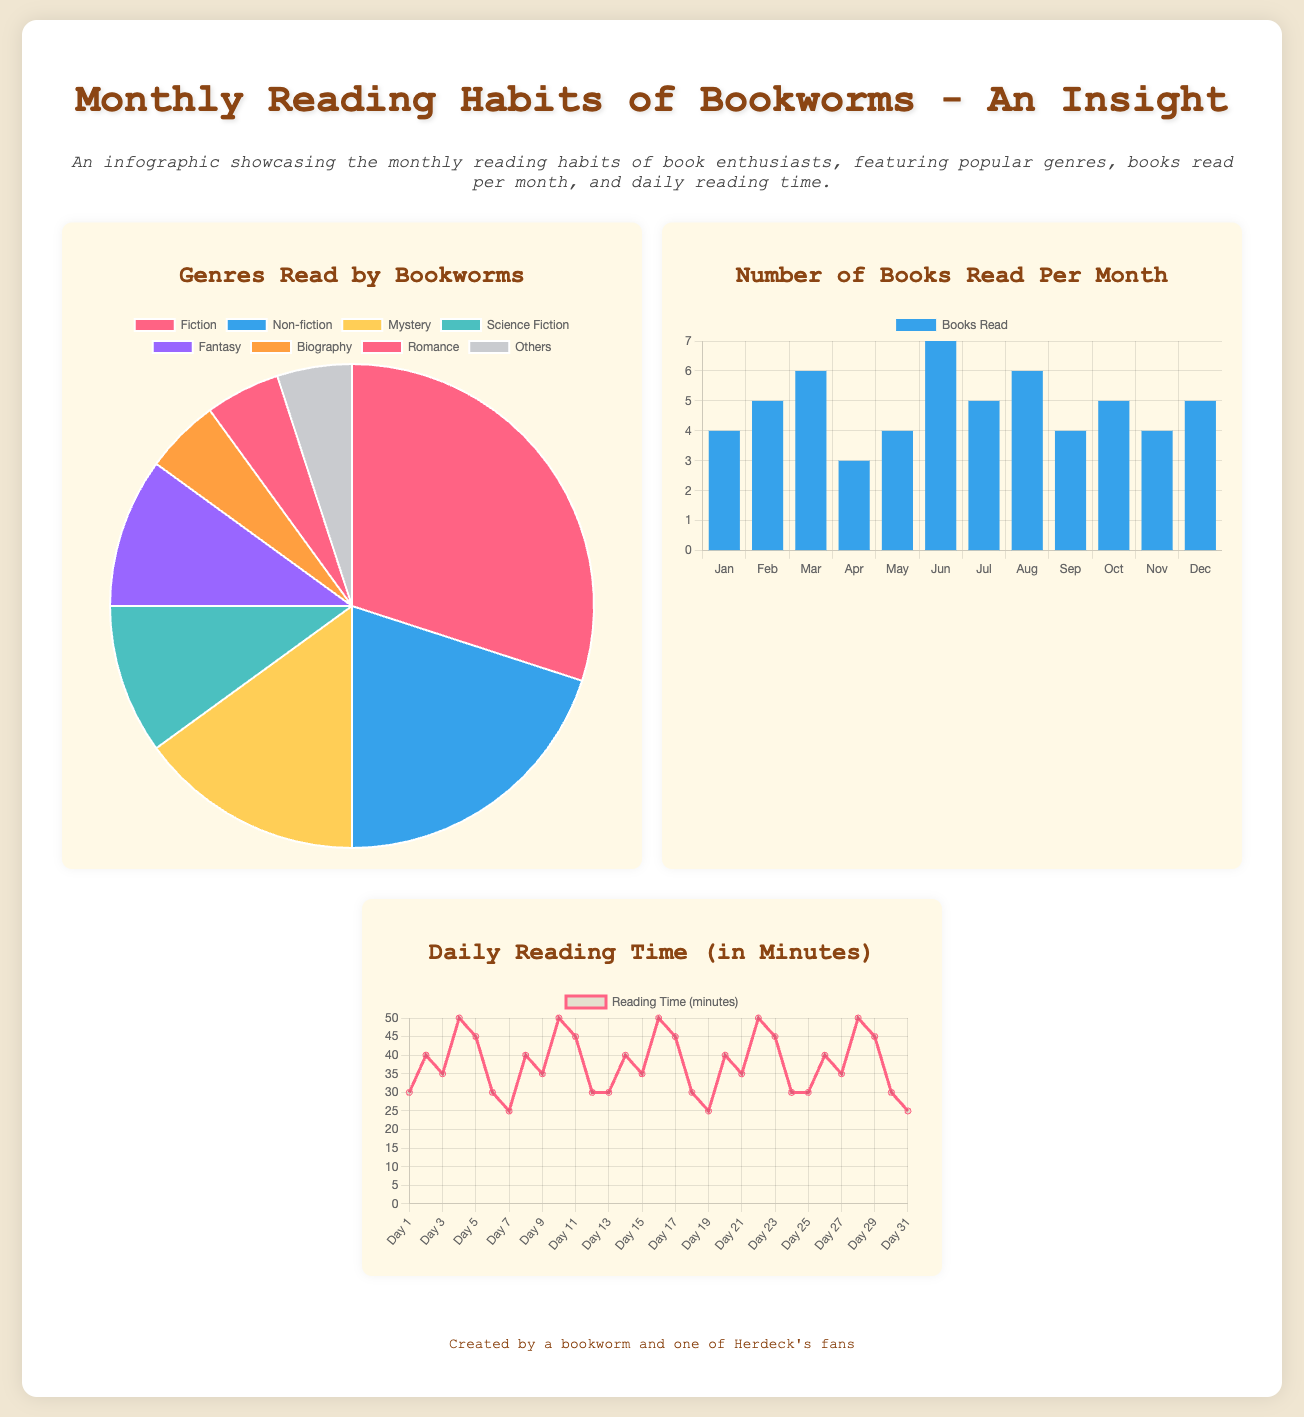What is the most popular genre among bookworms? The pie chart shows the distribution of genres read by bookworms, where Fiction makes up the largest segment.
Answer: Fiction How many books were read in March? The bar graph indicates the number of books read in each month, showing that 6 books were read in March.
Answer: 6 What is the average daily reading time for bookworms in minutes? The line chart presents daily reading times, demonstrating a varied average; a quick review reveals values around 35-45 minutes per day.
Answer: Approximately 35-45 minutes How many genres are listed in the infographic? The pie chart displays the genre data, and upon counting, there are 8 distinct genres displayed.
Answer: 8 What month had the highest number of books read? The bar graph indicates that June had the highest number of books read with a total of 7 books.
Answer: June What is the reading time on Day 10? From the line chart, it can be observed that on Day 10, the reading time was recorded as 50 minutes.
Answer: 50 minutes Which genre has the smallest share in the reading habits? The pie chart indicates that the genre with the smallest share is Biography, with only 5%.
Answer: Biography In which month did bookworms read the least number of books? The bar graph shows that April had the least number of books read, totaling 3.
Answer: April 